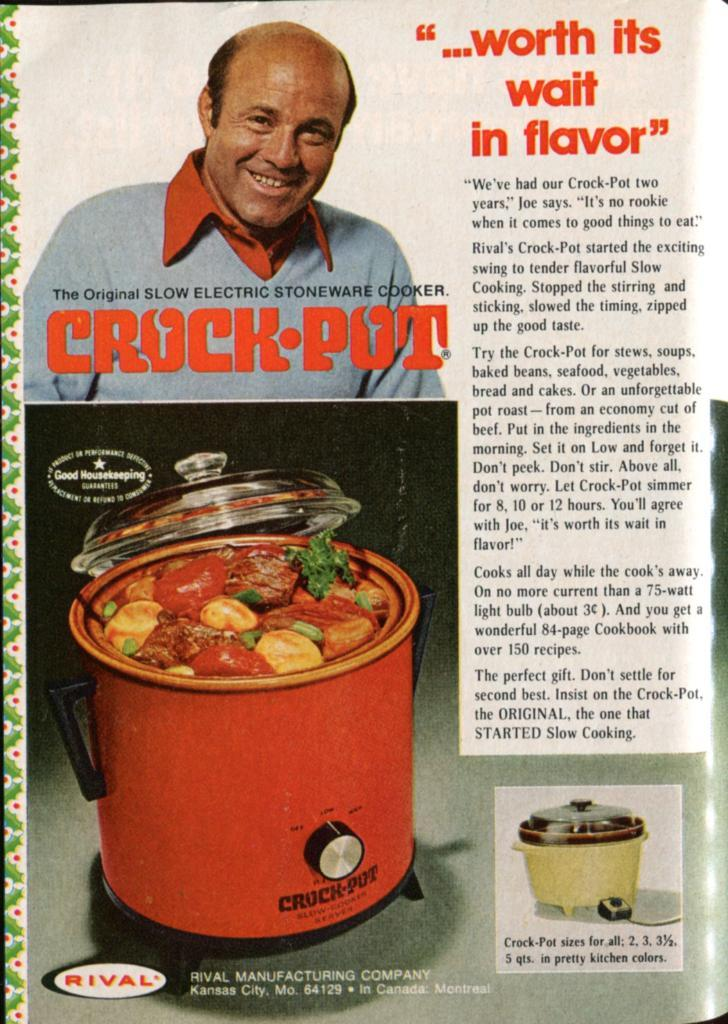<image>
Offer a succinct explanation of the picture presented. Page from a magazine that says "Crock Pot" on it. 